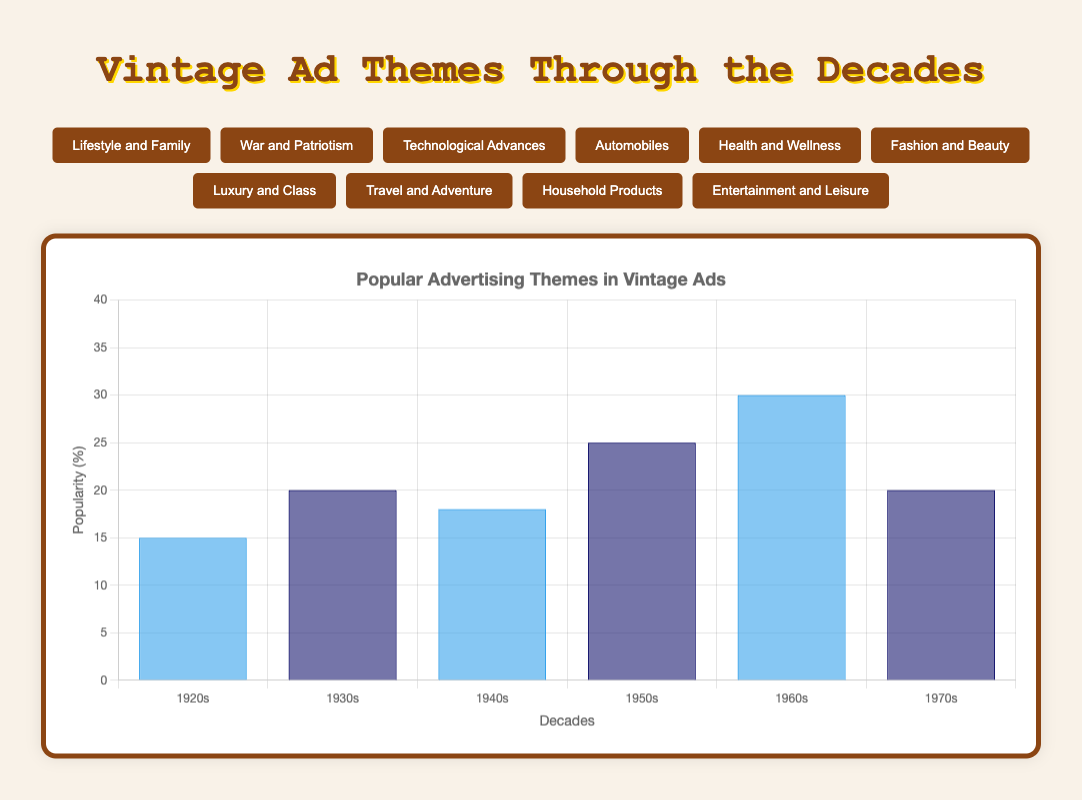Which decade had the highest popularity for the theme "War and Patriotism"? The figure shows the popularity of "War and Patriotism" over different decades. By visually inspecting the height of the bars for "War and Patriotism," the 1940s has the highest bar compared to other decades.
Answer: 1940s Compare the popularity of "Health and Wellness" between the 1960s and 1970s. Which decade had a higher value? By looking at the bars for "Health and Wellness," the bar for the 1960s is higher compared to the 1970s. Thus, the 1960s had a higher popularity percentage for this theme.
Answer: 1960s What is the total sum of the popularity percentages for "Entertainment and Leisure" across all decades? Sum the popularity values given for "Entertainment and Leisure" across the decades: 12 (1920s) + 15 (1930s) + 18 (1940s) + 25 (1950s) + 30 (1960s) + 35 (1970s) = 135.
Answer: 135 Which theme had a stronger presence in the 1950s: "Automobiles" or "Household Products"? Comparing the bars for the 1950s for both themes, "Household Products" has a higher bar (20) than "Automobiles" (20). Both themes are equally present in this decade.
Answer: Both are equal Calculate the average popularity percentage of "Fashion and Beauty" over the given decades. Add the popularity percentages of "Fashion and Beauty" for all decades and divide by the number of decades: (18 + 25 + 20 + 30 + 35 + 28) / 6 = 156 / 6 = 26.
Answer: 26 Which decade saw the greatest increase in popularity for "Technological Advances" compared to its previous decade? Compare the differences between consecutive decades for "Technological Advances": 
1930s - 1920s: 5 - 8 = -3,
1940s - 1930s: 10 - 5 = 5,
1950s - 1940s: 15 - 10 = 5,
1960s - 1950s: 20 - 15 = 5,
1970s - 1960s: 25 - 20 = 5. The greatest increase occurs in the 1940s, 1950s, 1960s, and 1970s, which is 5 percent.
Answer: 1940s, 1950s, 1960s, and 1970s Is there any decade where the popularity of "Luxury and Class" remained the same as the previous decade? By comparing the values for consecutive decades for "Luxury and Class": 1920s (10), 1930s (8), 1940s (10), 1950s (15), 1960s (18), and 1970s (22), we can see that there is no decade where the value remained the same as the previous decade.
Answer: No What was the most popular theme in the 1930s? By examining the height of the bars for the 1930s, we can see that the highest bar represents "Fashion and Beauty," indicating it was the most popular theme.
Answer: Fashion and Beauty Compare the popularity of "Travel and Adventure" in the 1920s and 1930s. What difference do you observe? Subtract the popularity of "Travel and Adventure" in the 1920s (6) from the popularity in the 1930s (7): 7 - 6 = 1. The theme had a 1 percent increase in popularity from the 1920s to the 1930s.
Answer: 1% increase 